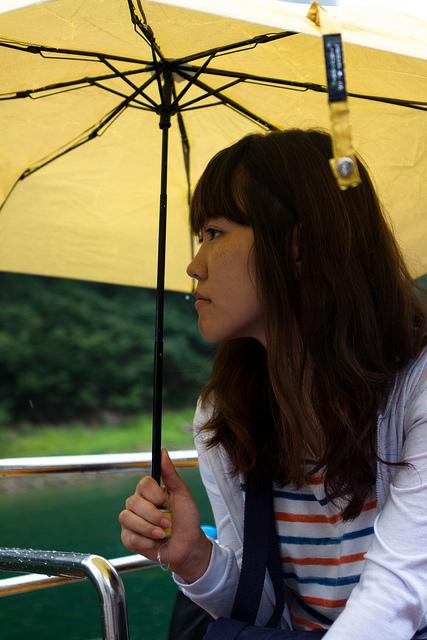When the rain stops how will this umbrella be stored? Please explain your reasoning. folded. There are mechanisms that fold in on themselves on the umbrella. 